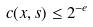<formula> <loc_0><loc_0><loc_500><loc_500>c ( x , s ) \leq 2 ^ { - e }</formula> 